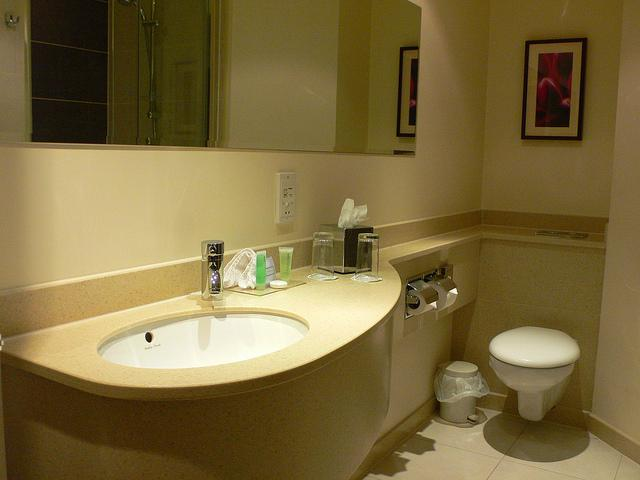What is missing from this picture? shower 